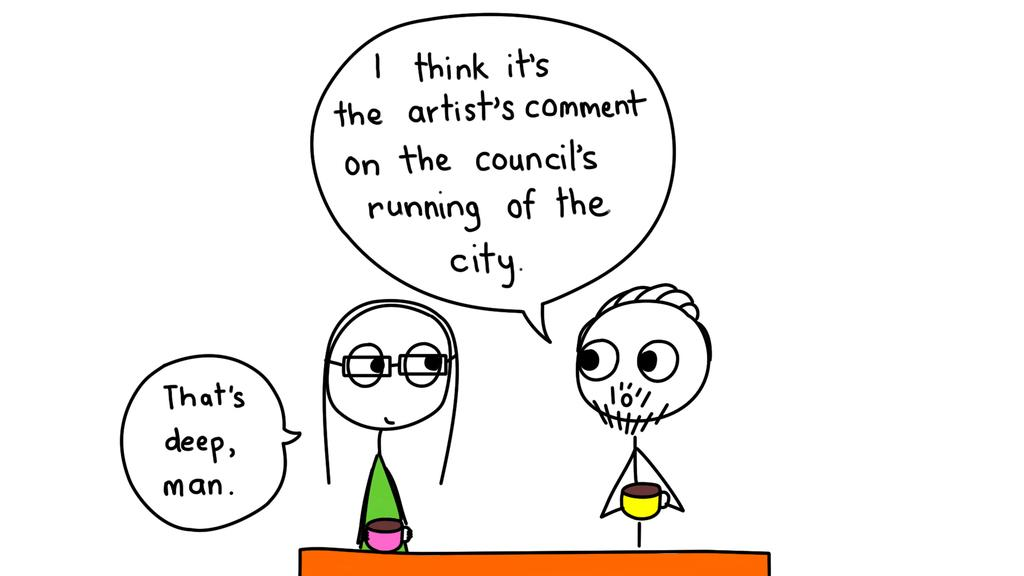What type of image is being described? The image appears to be an animation. How many people are present in the image? There are two persons in the image. What are the persons holding in their hands? The persons are holding cups. Can you describe the text present in the image? There is text written on the left side and top of the image. What type of sticks can be seen floating in the lake in the image? There is no lake or sticks present in the image; it is an animation featuring two persons holding cups. 